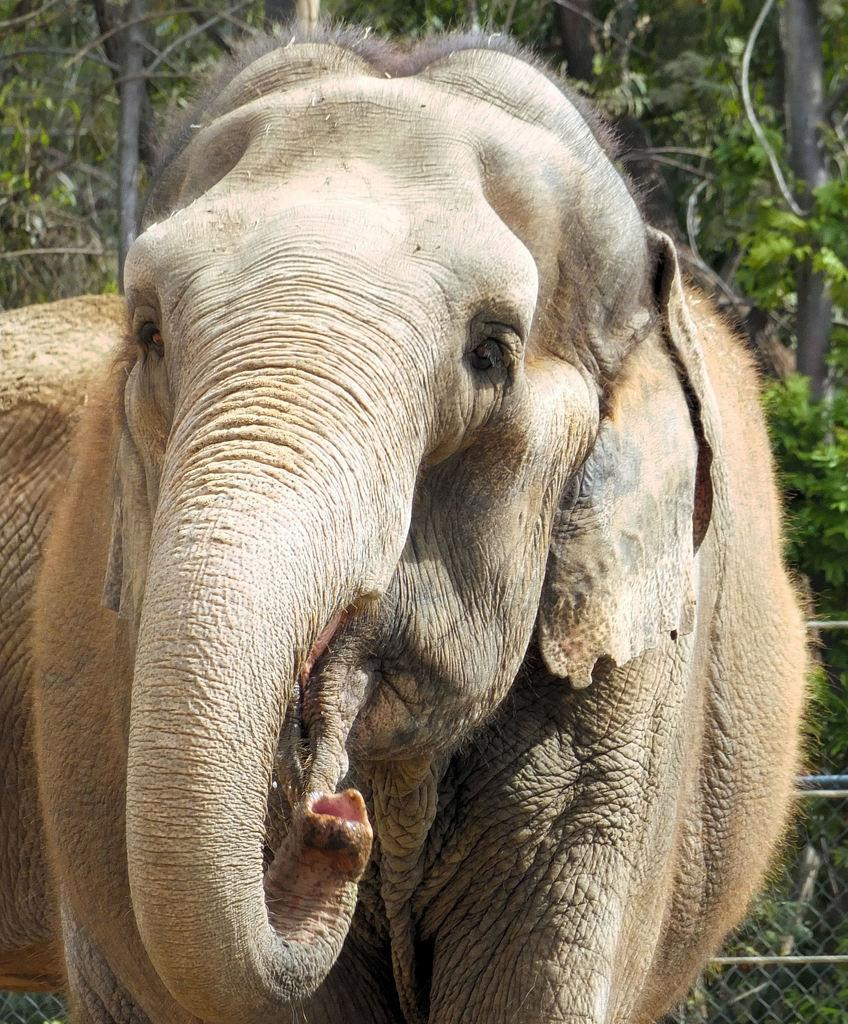What animals are present in the image? There are elephants in the image. What can be seen in the background of the image? There is a fence and trees in the background of the image. What type of crime is being committed by the elephants in the image? There is no crime being committed by the elephants in the image; they are simply present in the scene. 